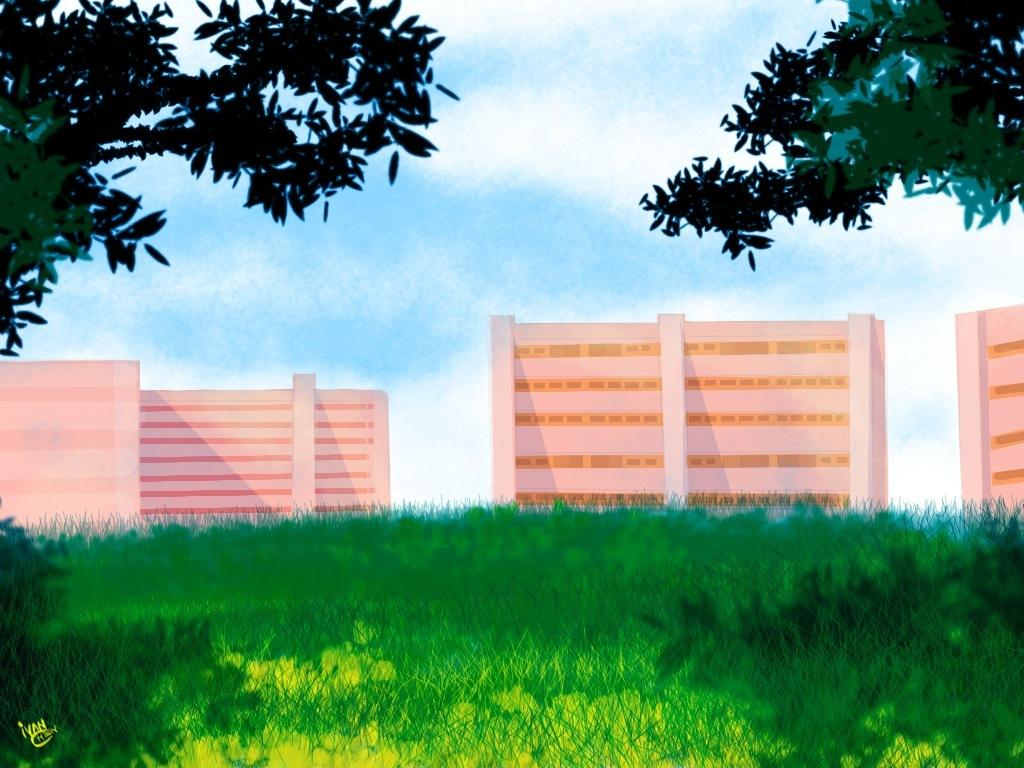What type of vegetation is present in the image? There is grass in the image. What structure can be seen in the image? There is a fence wall in the image. What is located on either side of the fence wall? There are trees on either side of the fence wall. How many boats are visible in the image? There are no boats present in the image. What type of fruit is being crushed in the image? There is no fruit or crushing activity present in the image. 